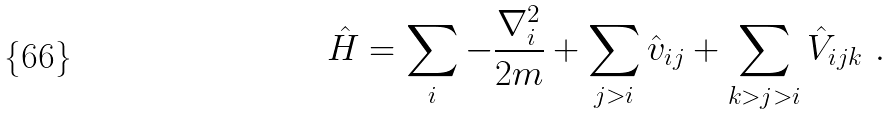Convert formula to latex. <formula><loc_0><loc_0><loc_500><loc_500>\hat { H } = \sum _ { i } - \frac { { \nabla } ^ { 2 } _ { i } } { 2 m } + \sum _ { j > i } \hat { v } _ { i j } + \sum _ { k > j > i } \hat { V } _ { i j k } \ .</formula> 